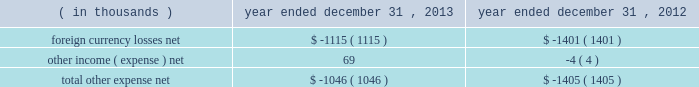Other expense , net : the company's other expense consists of the following: .
Income tax provision : the company recorded income tax expense of $ 77.2 million and had income before income taxes of $ 322.5 million for the year ended december 31 , 2013 , representing an effective tax rate of 23.9% ( 23.9 % ) .
During the year ended december 31 , 2012 , the company recorded income tax expense of $ 90.1 million and had income before income taxes of $ 293.5 million , representing an effective tax rate of 30.7% ( 30.7 % ) .
In december 2013 , the company received notice from the irs that the joint committee on taxation took no exception to the company's tax returns that were filed for 2009 and 2010 .
An $ 11.0 million tax benefit was recognized in the company's 2013 financial results as the company had effectively settled uncertainty regarding the realization of refund claims filed in connection with the 2009 and 2010 returns .
In the u.s. , which is the largest jurisdiction where the company receives such a tax credit , the availability of the research and development credit expired at the end of the 2011 tax year .
In january 2013 , the u.s .
Congress passed legislation that reinstated the research and development credit retroactive to 2012 .
The income tax provision for the year ended december 31 , 2013 includes approximately $ 2.3 million related to the reinstated research and development credit for 2012 activity .
The decrease in the effective tax rate from the prior year is primarily due to the release of an uncertain tax position mentioned above , the reinstatement of the u.s .
Research and development credit mentioned above , and cash repatriation activities .
When compared to the federal and state combined statutory rate , the effective tax rates for the years ended december 31 , 2013 and 2012 were favorably impacted by lower statutory tax rates in many of the company 2019s foreign jurisdictions , the domestic manufacturing deduction and tax benefits associated with the merger of the company 2019s japan subsidiaries in 2010 .
Net income : the company 2019s net income for the year ended december 31 , 2013 was $ 245.3 million as compared to net income of $ 203.5 million for the year ended december 31 , 2012 .
Diluted earnings per share was $ 2.58 for the year ended december 31 , 2013 and $ 2.14 for the year ended december 31 , 2012 .
The weighted average shares used in computing diluted earnings per share were 95.1 million and 95.0 million for the years ended december 31 , 2013 and 2012 , respectively .
Table of contents .
What was the percentage decrease in net come for the year ended 2013 to the year ended 2012? 
Computations: ((245.3 - 203.5) / 245.3)
Answer: 0.1704. 